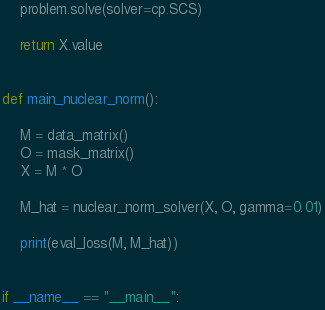<code> <loc_0><loc_0><loc_500><loc_500><_Python_>    problem.solve(solver=cp.SCS)

    return X.value 


def main_nuclear_norm():

    M = data_matrix()
    O = mask_matrix()
    X = M * O

    M_hat = nuclear_norm_solver(X, O, gamma=0.01)

    print(eval_loss(M, M_hat))


if __name__ == "__main__":</code> 